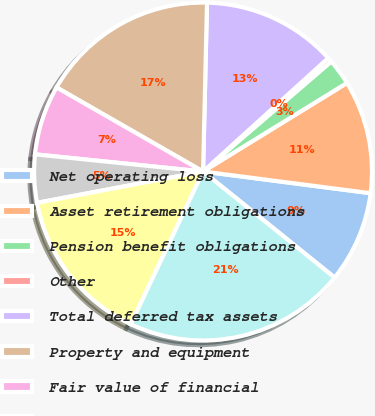Convert chart. <chart><loc_0><loc_0><loc_500><loc_500><pie_chart><fcel>Net operating loss<fcel>Asset retirement obligations<fcel>Pension benefit obligations<fcel>Other<fcel>Total deferred tax assets<fcel>Property and equipment<fcel>Fair value of financial<fcel>Long-term debt<fcel>Taxes on unremitted foreign<fcel>Total deferred tax liabilities<nl><fcel>8.75%<fcel>10.83%<fcel>2.51%<fcel>0.43%<fcel>12.91%<fcel>17.08%<fcel>6.67%<fcel>4.59%<fcel>15.0%<fcel>21.24%<nl></chart> 